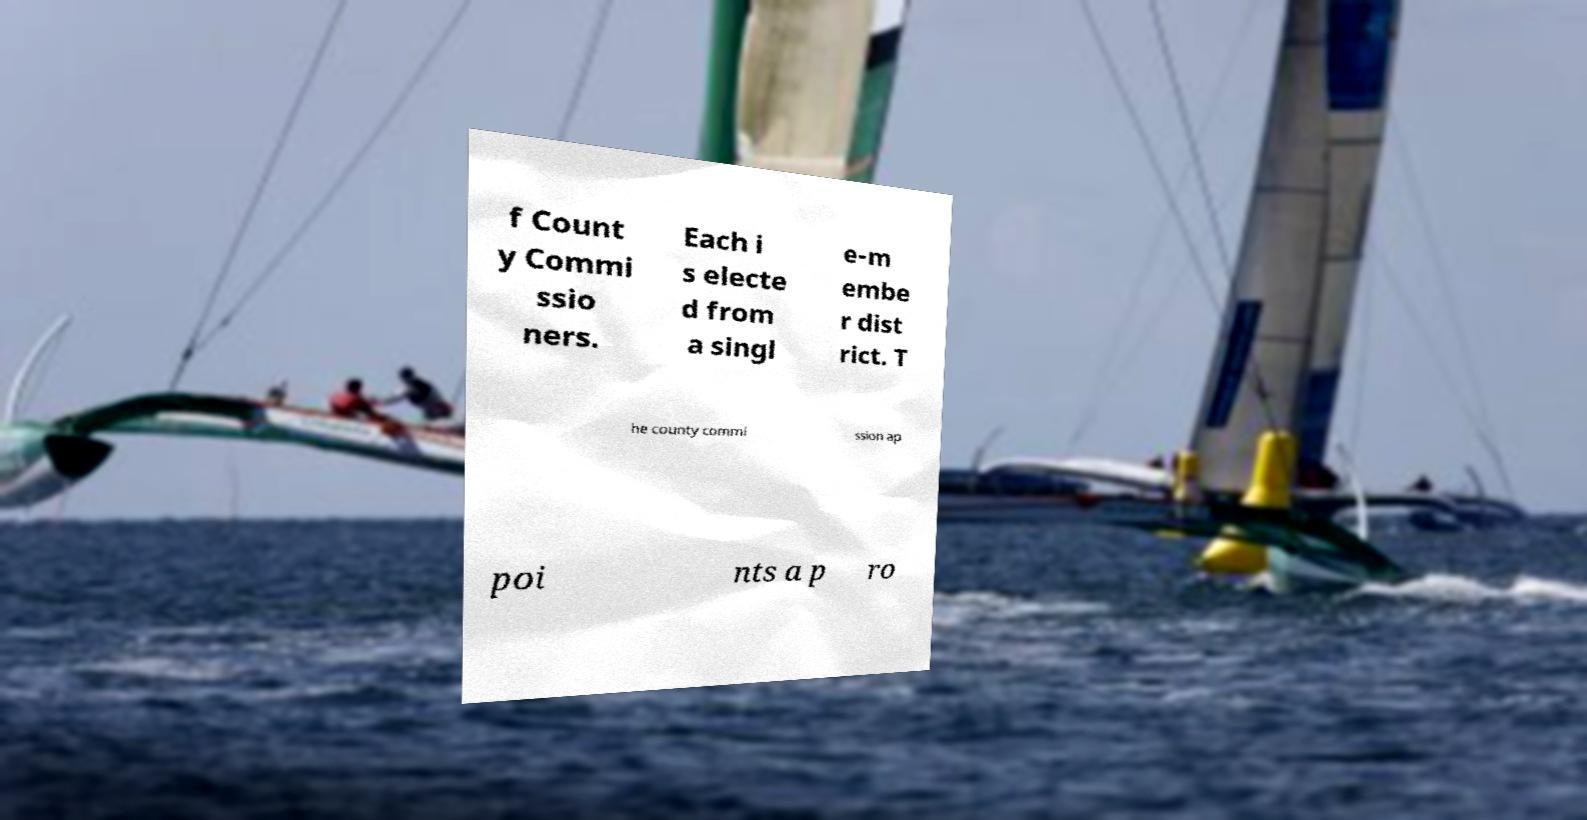What messages or text are displayed in this image? I need them in a readable, typed format. f Count y Commi ssio ners. Each i s electe d from a singl e-m embe r dist rict. T he county commi ssion ap poi nts a p ro 